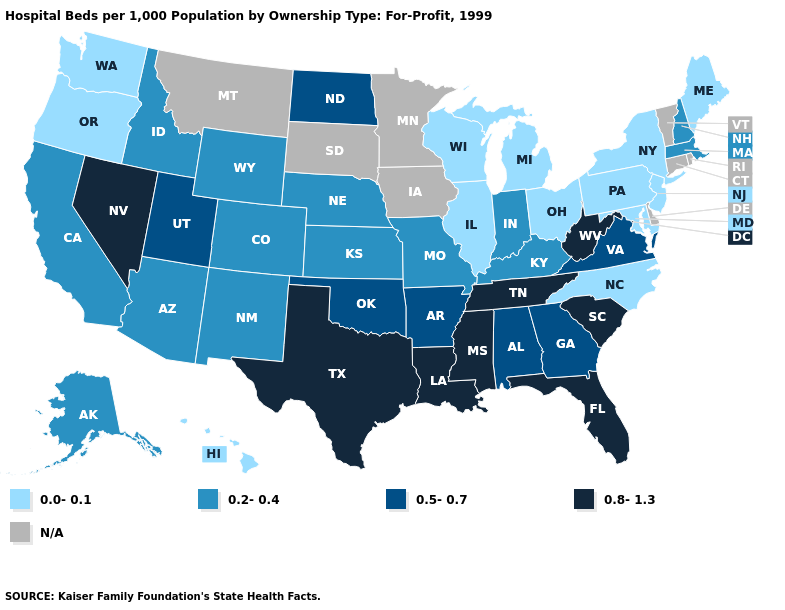Does the first symbol in the legend represent the smallest category?
Give a very brief answer. Yes. Does Texas have the highest value in the USA?
Short answer required. Yes. What is the value of Maryland?
Be succinct. 0.0-0.1. What is the value of Mississippi?
Be succinct. 0.8-1.3. Name the states that have a value in the range N/A?
Write a very short answer. Connecticut, Delaware, Iowa, Minnesota, Montana, Rhode Island, South Dakota, Vermont. Does the map have missing data?
Answer briefly. Yes. What is the value of New York?
Keep it brief. 0.0-0.1. What is the value of New Hampshire?
Give a very brief answer. 0.2-0.4. What is the value of Alabama?
Keep it brief. 0.5-0.7. Among the states that border West Virginia , which have the highest value?
Quick response, please. Virginia. Which states have the lowest value in the USA?
Be succinct. Hawaii, Illinois, Maine, Maryland, Michigan, New Jersey, New York, North Carolina, Ohio, Oregon, Pennsylvania, Washington, Wisconsin. What is the value of New Hampshire?
Concise answer only. 0.2-0.4. What is the value of West Virginia?
Short answer required. 0.8-1.3. Name the states that have a value in the range 0.0-0.1?
Concise answer only. Hawaii, Illinois, Maine, Maryland, Michigan, New Jersey, New York, North Carolina, Ohio, Oregon, Pennsylvania, Washington, Wisconsin. What is the value of Illinois?
Write a very short answer. 0.0-0.1. 